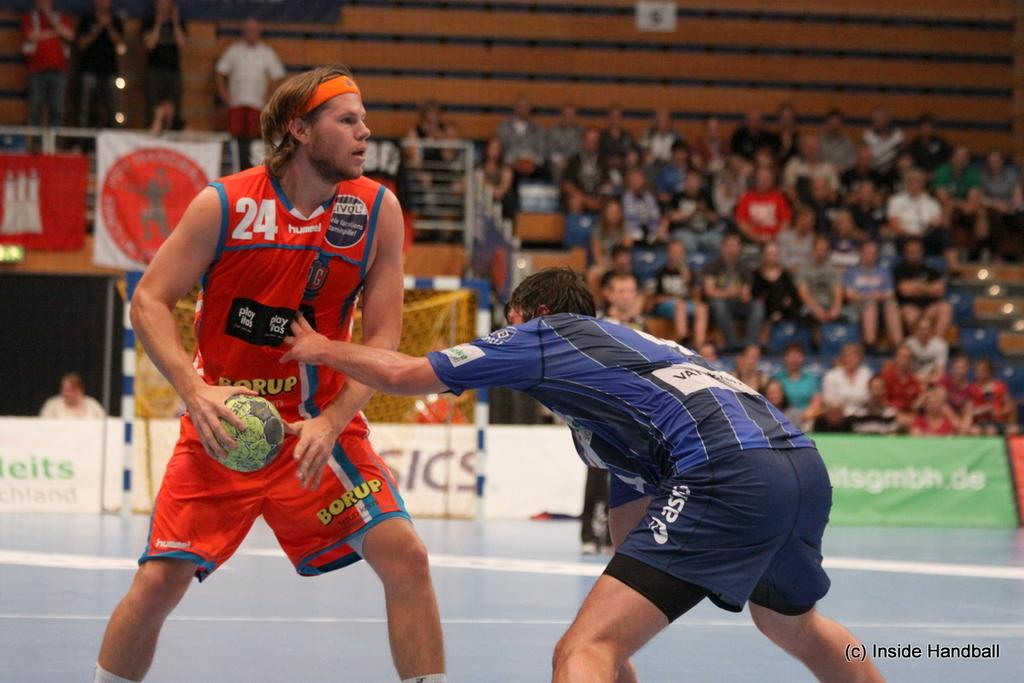<image>
Give a short and clear explanation of the subsequent image. Player with a ball in his hand and hummel on his shirt. 